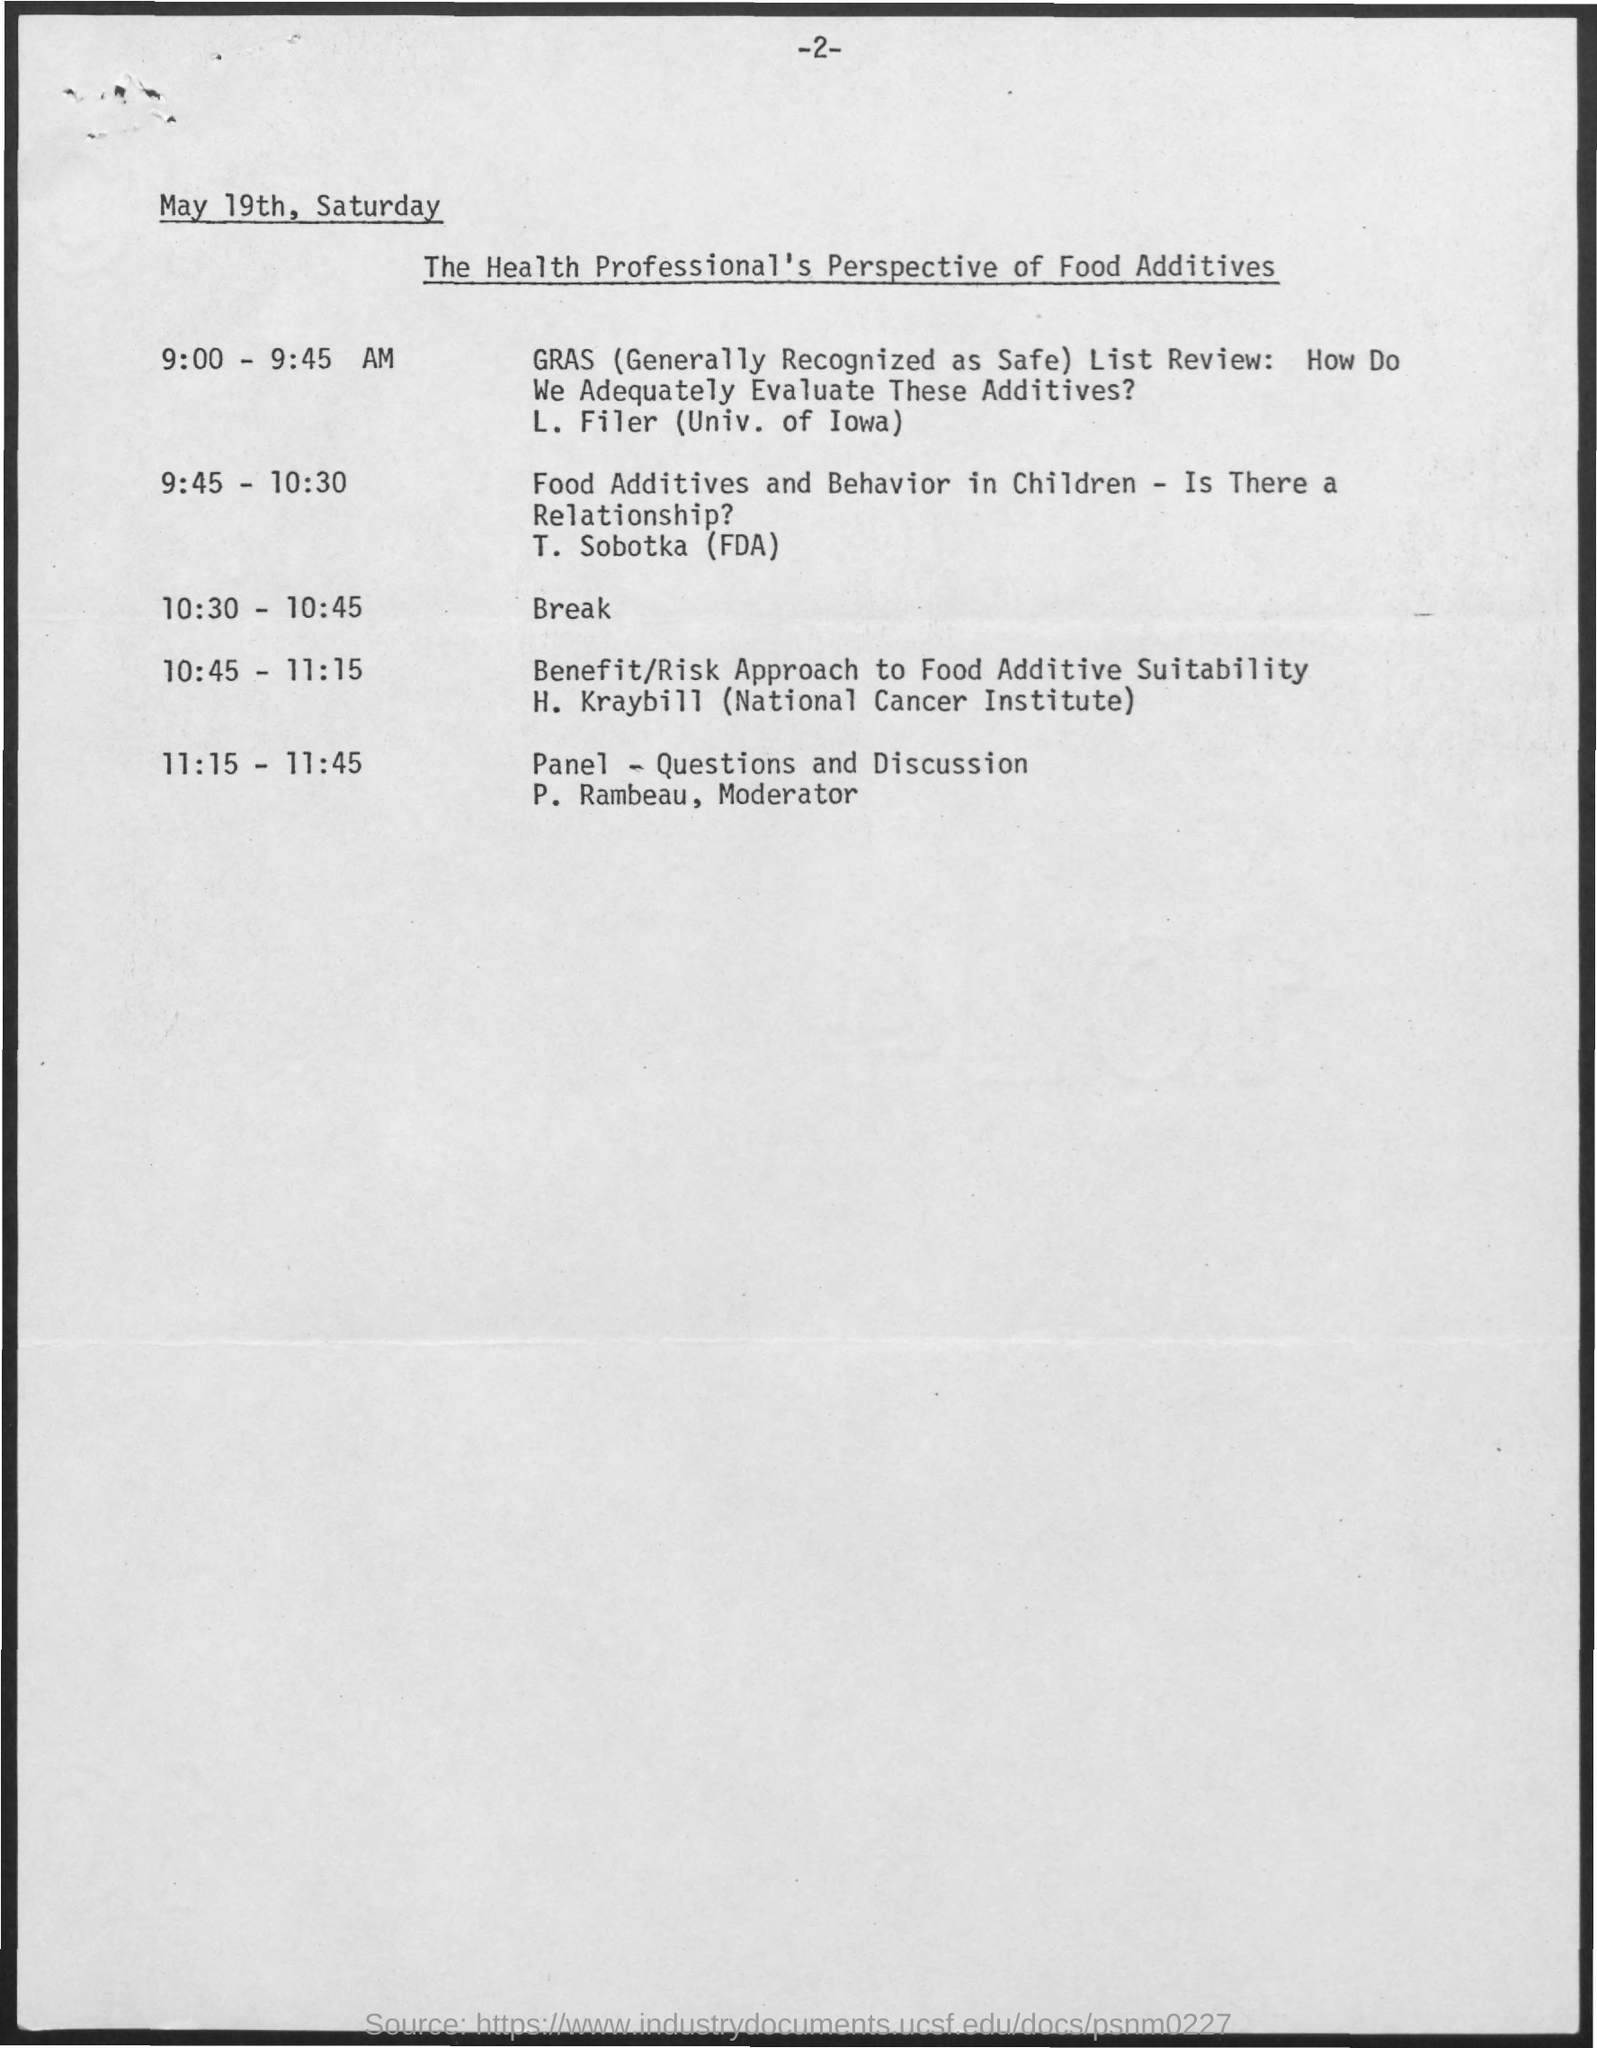Mention a couple of crucial points in this snapshot. The session is being carried out by T. Sobotka (FDA) from 9:45 to 10:30. P. Rambeau is referred to as the Moderator for the Panel - Questions and Discussion. What time is the provided break from 10:30 to 10:45? GRAS stands for "Generally Recognized as Safe" and is a classification used by the US Food and Drug Administration (FDA) to indicate that a substance is considered safe for consumption based on common knowledge and scientific evidence. 